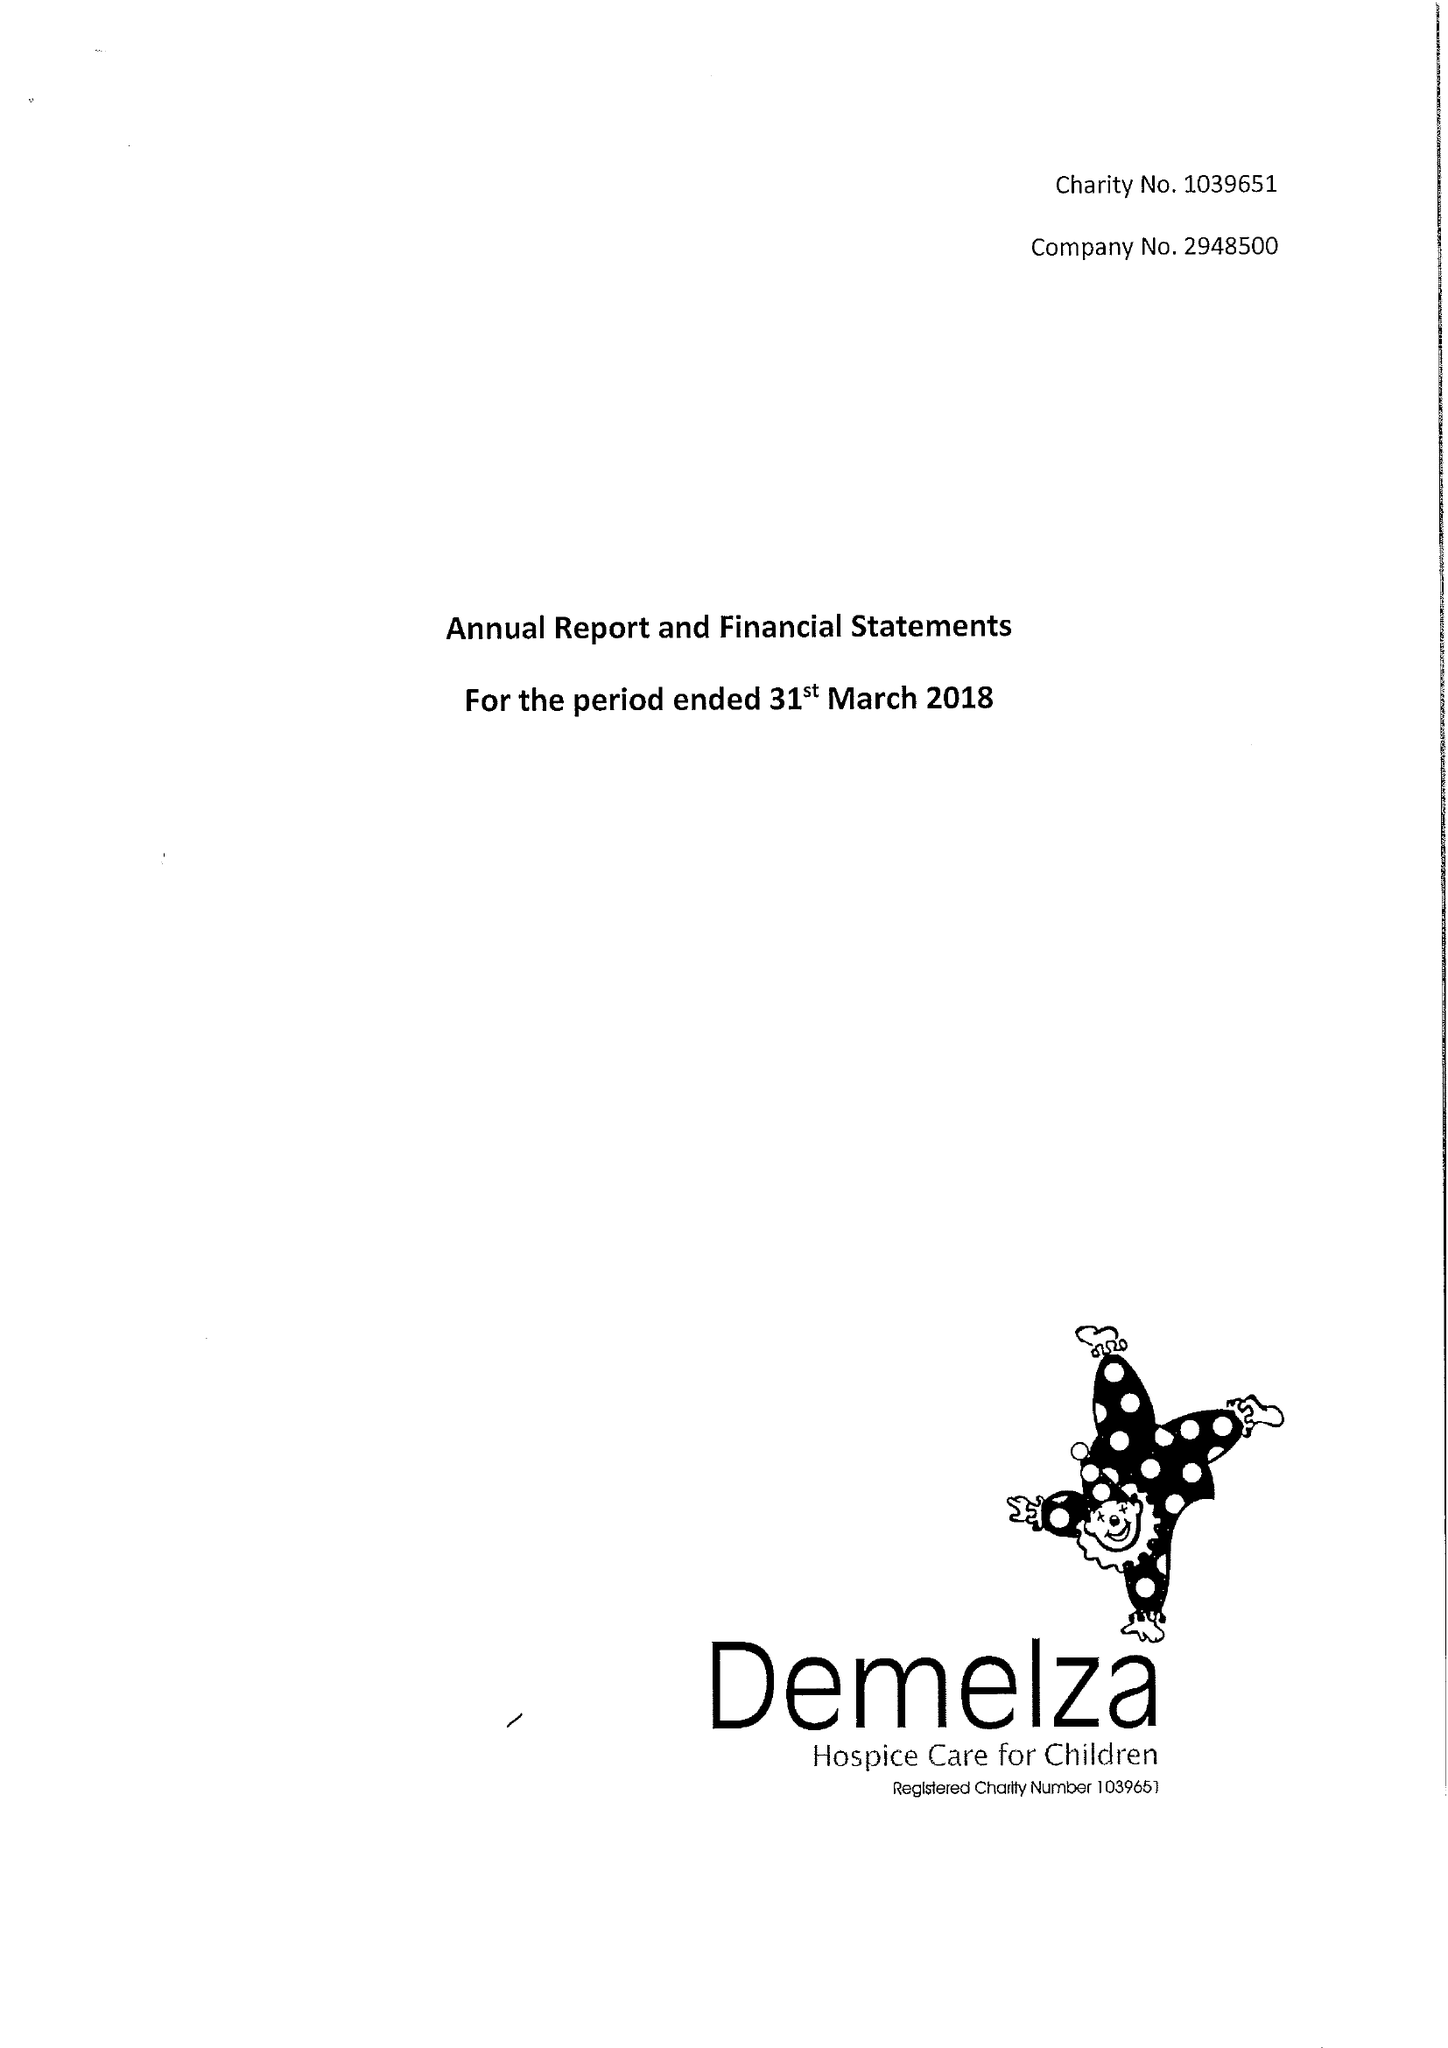What is the value for the address__postcode?
Answer the question using a single word or phrase. ME9 8DZ 